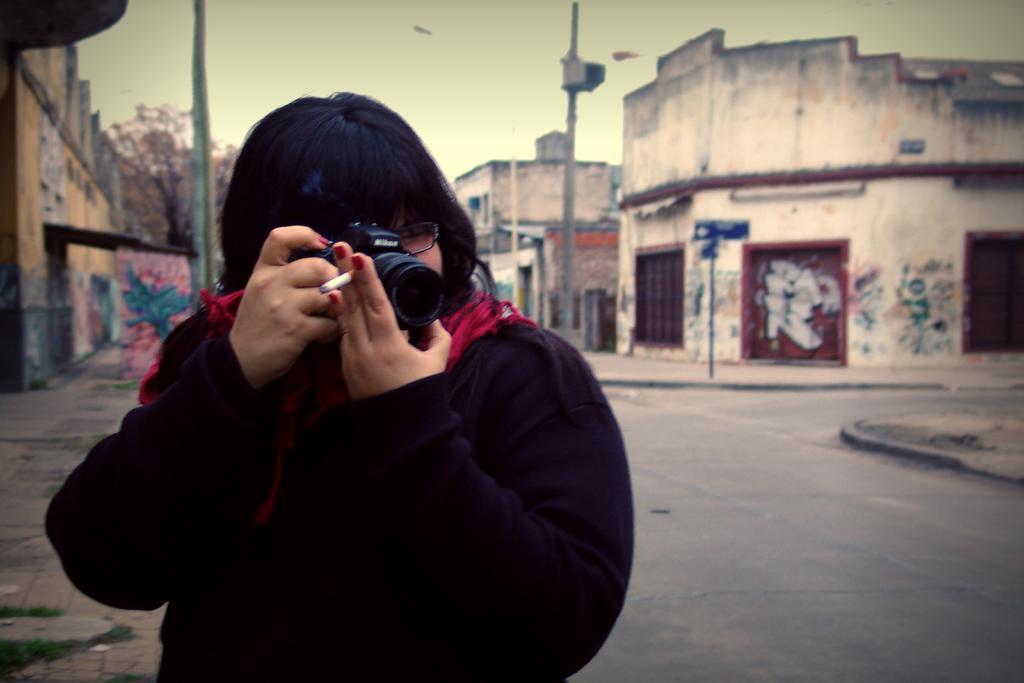Describe this image in one or two sentences. In this image, In the left side there is a woman standing and holding a camera which is in black color, In the right side there is a road and there is a wall which is in white color and there is a pole which is in gray color. 